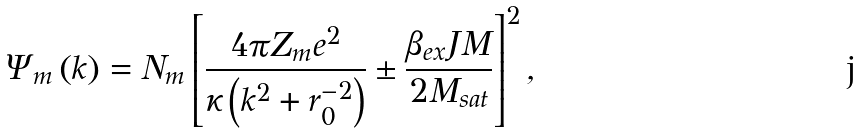Convert formula to latex. <formula><loc_0><loc_0><loc_500><loc_500>\Psi _ { m } \left ( k \right ) = N _ { m } \left [ \frac { 4 \pi Z _ { m } e ^ { 2 } } { \kappa \left ( k ^ { 2 } + r _ { 0 } ^ { - 2 } \right ) } \pm \frac { \beta _ { e x } J M } { 2 M _ { s a t } } \right ] ^ { 2 } ,</formula> 